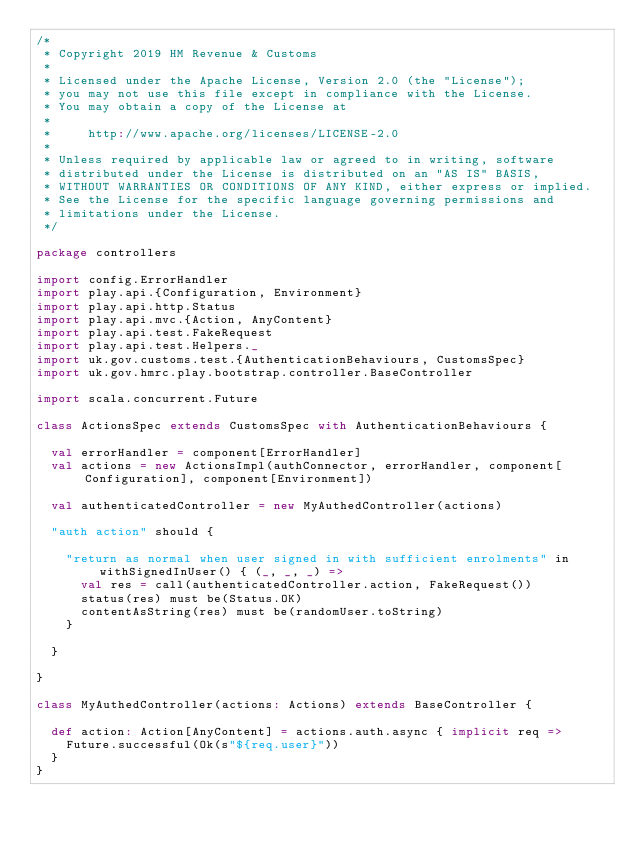Convert code to text. <code><loc_0><loc_0><loc_500><loc_500><_Scala_>/*
 * Copyright 2019 HM Revenue & Customs
 *
 * Licensed under the Apache License, Version 2.0 (the "License");
 * you may not use this file except in compliance with the License.
 * You may obtain a copy of the License at
 *
 *     http://www.apache.org/licenses/LICENSE-2.0
 *
 * Unless required by applicable law or agreed to in writing, software
 * distributed under the License is distributed on an "AS IS" BASIS,
 * WITHOUT WARRANTIES OR CONDITIONS OF ANY KIND, either express or implied.
 * See the License for the specific language governing permissions and
 * limitations under the License.
 */

package controllers

import config.ErrorHandler
import play.api.{Configuration, Environment}
import play.api.http.Status
import play.api.mvc.{Action, AnyContent}
import play.api.test.FakeRequest
import play.api.test.Helpers._
import uk.gov.customs.test.{AuthenticationBehaviours, CustomsSpec}
import uk.gov.hmrc.play.bootstrap.controller.BaseController

import scala.concurrent.Future

class ActionsSpec extends CustomsSpec with AuthenticationBehaviours {

  val errorHandler = component[ErrorHandler]
  val actions = new ActionsImpl(authConnector, errorHandler, component[Configuration], component[Environment])

  val authenticatedController = new MyAuthedController(actions)

  "auth action" should {

    "return as normal when user signed in with sufficient enrolments" in withSignedInUser() { (_, _, _) =>
      val res = call(authenticatedController.action, FakeRequest())
      status(res) must be(Status.OK)
      contentAsString(res) must be(randomUser.toString)
    }

  }

}

class MyAuthedController(actions: Actions) extends BaseController {

  def action: Action[AnyContent] = actions.auth.async { implicit req =>
    Future.successful(Ok(s"${req.user}"))
  }
}
</code> 